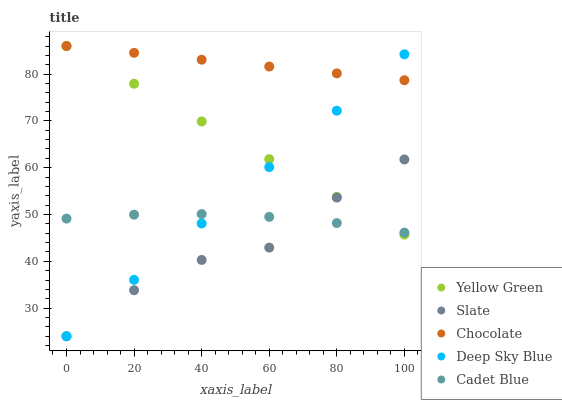Does Slate have the minimum area under the curve?
Answer yes or no. Yes. Does Chocolate have the maximum area under the curve?
Answer yes or no. Yes. Does Cadet Blue have the minimum area under the curve?
Answer yes or no. No. Does Cadet Blue have the maximum area under the curve?
Answer yes or no. No. Is Chocolate the smoothest?
Answer yes or no. Yes. Is Slate the roughest?
Answer yes or no. Yes. Is Cadet Blue the smoothest?
Answer yes or no. No. Is Cadet Blue the roughest?
Answer yes or no. No. Does Slate have the lowest value?
Answer yes or no. Yes. Does Cadet Blue have the lowest value?
Answer yes or no. No. Does Chocolate have the highest value?
Answer yes or no. Yes. Does Cadet Blue have the highest value?
Answer yes or no. No. Is Slate less than Chocolate?
Answer yes or no. Yes. Is Chocolate greater than Slate?
Answer yes or no. Yes. Does Deep Sky Blue intersect Cadet Blue?
Answer yes or no. Yes. Is Deep Sky Blue less than Cadet Blue?
Answer yes or no. No. Is Deep Sky Blue greater than Cadet Blue?
Answer yes or no. No. Does Slate intersect Chocolate?
Answer yes or no. No. 